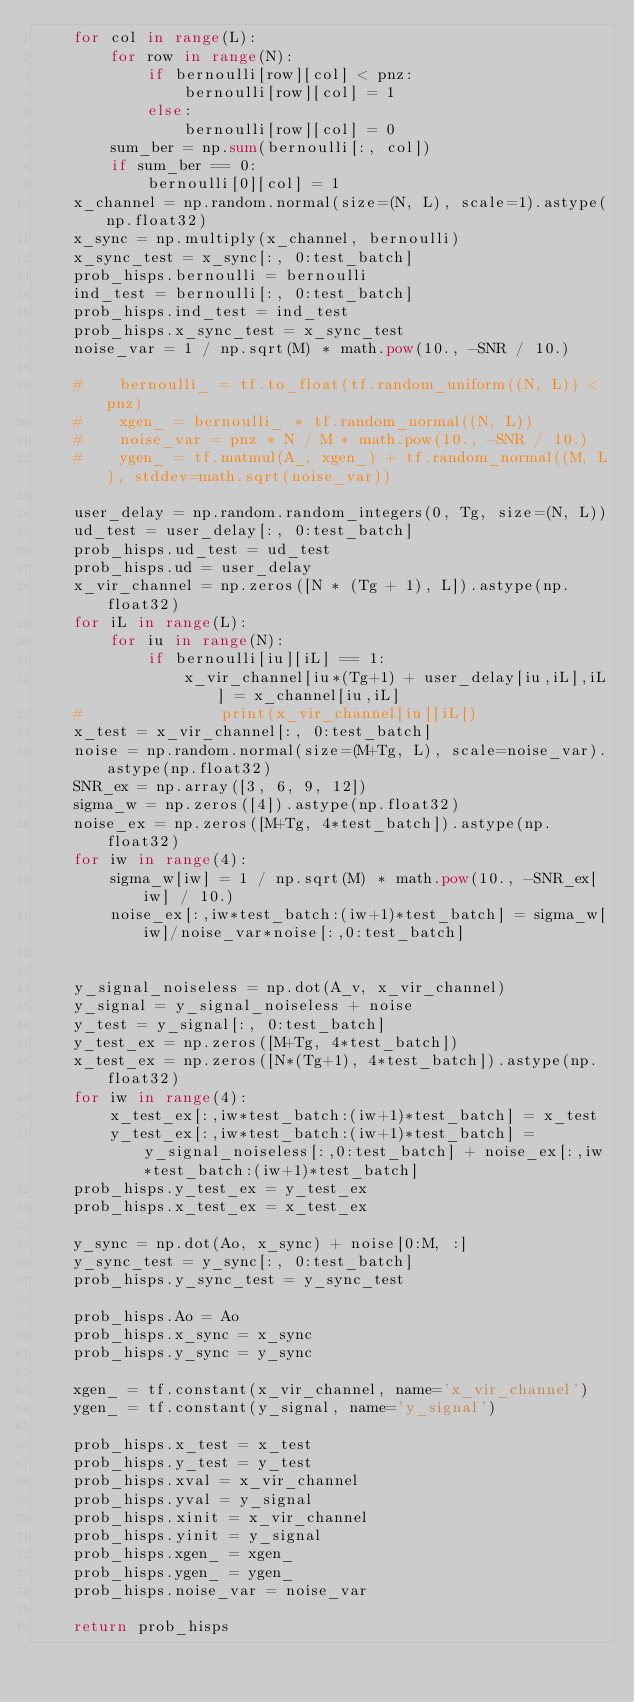Convert code to text. <code><loc_0><loc_0><loc_500><loc_500><_Python_>    for col in range(L):
        for row in range(N):
            if bernoulli[row][col] < pnz:
                bernoulli[row][col] = 1
            else:
                bernoulli[row][col] = 0
        sum_ber = np.sum(bernoulli[:, col])
        if sum_ber == 0:
            bernoulli[0][col] = 1
    x_channel = np.random.normal(size=(N, L), scale=1).astype(np.float32)
    x_sync = np.multiply(x_channel, bernoulli)
    x_sync_test = x_sync[:, 0:test_batch]
    prob_hisps.bernoulli = bernoulli
    ind_test = bernoulli[:, 0:test_batch]
    prob_hisps.ind_test = ind_test
    prob_hisps.x_sync_test = x_sync_test
    noise_var = 1 / np.sqrt(M) * math.pow(10., -SNR / 10.)

    #    bernoulli_ = tf.to_float(tf.random_uniform((N, L)) < pnz)
    #    xgen_ = bernoulli_ * tf.random_normal((N, L))
    #    noise_var = pnz * N / M * math.pow(10., -SNR / 10.)
    #    ygen_ = tf.matmul(A_, xgen_) + tf.random_normal((M, L), stddev=math.sqrt(noise_var))

    user_delay = np.random.random_integers(0, Tg, size=(N, L))
    ud_test = user_delay[:, 0:test_batch]
    prob_hisps.ud_test = ud_test
    prob_hisps.ud = user_delay
    x_vir_channel = np.zeros([N * (Tg + 1), L]).astype(np.float32)
    for iL in range(L):
        for iu in range(N):
            if bernoulli[iu][iL] == 1:
                x_vir_channel[iu*(Tg+1) + user_delay[iu,iL],iL] = x_channel[iu,iL]
    #               print(x_vir_channel[iu][iL])
    x_test = x_vir_channel[:, 0:test_batch]
    noise = np.random.normal(size=(M+Tg, L), scale=noise_var).astype(np.float32)
    SNR_ex = np.array([3, 6, 9, 12])
    sigma_w = np.zeros([4]).astype(np.float32)
    noise_ex = np.zeros([M+Tg, 4*test_batch]).astype(np.float32)
    for iw in range(4):
        sigma_w[iw] = 1 / np.sqrt(M) * math.pow(10., -SNR_ex[iw] / 10.)
        noise_ex[:,iw*test_batch:(iw+1)*test_batch] = sigma_w[iw]/noise_var*noise[:,0:test_batch]


    y_signal_noiseless = np.dot(A_v, x_vir_channel)
    y_signal = y_signal_noiseless + noise
    y_test = y_signal[:, 0:test_batch]
    y_test_ex = np.zeros([M+Tg, 4*test_batch])
    x_test_ex = np.zeros([N*(Tg+1), 4*test_batch]).astype(np.float32)
    for iw in range(4):
        x_test_ex[:,iw*test_batch:(iw+1)*test_batch] = x_test
        y_test_ex[:,iw*test_batch:(iw+1)*test_batch] = y_signal_noiseless[:,0:test_batch] + noise_ex[:,iw*test_batch:(iw+1)*test_batch]
    prob_hisps.y_test_ex = y_test_ex
    prob_hisps.x_test_ex = x_test_ex

    y_sync = np.dot(Ao, x_sync) + noise[0:M, :]
    y_sync_test = y_sync[:, 0:test_batch]
    prob_hisps.y_sync_test = y_sync_test

    prob_hisps.Ao = Ao
    prob_hisps.x_sync = x_sync
    prob_hisps.y_sync = y_sync

    xgen_ = tf.constant(x_vir_channel, name='x_vir_channel')
    ygen_ = tf.constant(y_signal, name='y_signal')

    prob_hisps.x_test = x_test
    prob_hisps.y_test = y_test
    prob_hisps.xval = x_vir_channel
    prob_hisps.yval = y_signal
    prob_hisps.xinit = x_vir_channel
    prob_hisps.yinit = y_signal
    prob_hisps.xgen_ = xgen_
    prob_hisps.ygen_ = ygen_
    prob_hisps.noise_var = noise_var

    return prob_hisps
</code> 